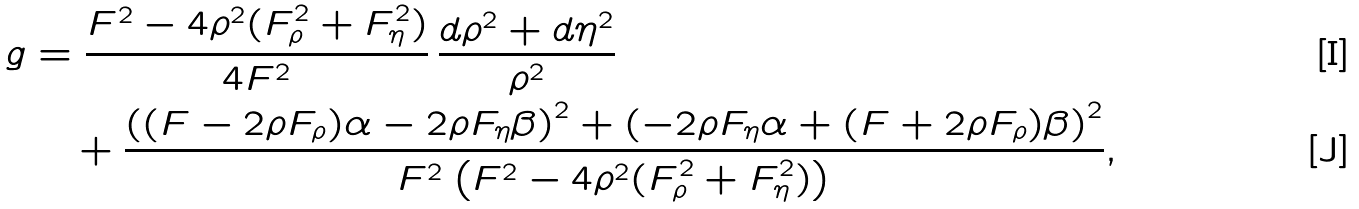Convert formula to latex. <formula><loc_0><loc_0><loc_500><loc_500>g & = \frac { F ^ { 2 } - 4 \rho ^ { 2 } ( F _ { \rho } ^ { 2 } + F _ { \eta } ^ { 2 } ) } { 4 F ^ { 2 } } \, \frac { d \rho ^ { 2 } + d \eta ^ { 2 } } { \rho ^ { 2 } } \\ & \quad + \frac { \left ( ( F - 2 \rho F _ { \rho } ) \alpha - 2 \rho F _ { \eta } \beta \right ) ^ { 2 } + \left ( - 2 \rho F _ { \eta } \alpha + ( F + 2 \rho F _ { \rho } ) \beta \right ) ^ { 2 } } { F ^ { 2 } \left ( F ^ { 2 } - 4 \rho ^ { 2 } ( F _ { \rho } ^ { 2 } + F _ { \eta } ^ { 2 } ) \right ) } ,</formula> 